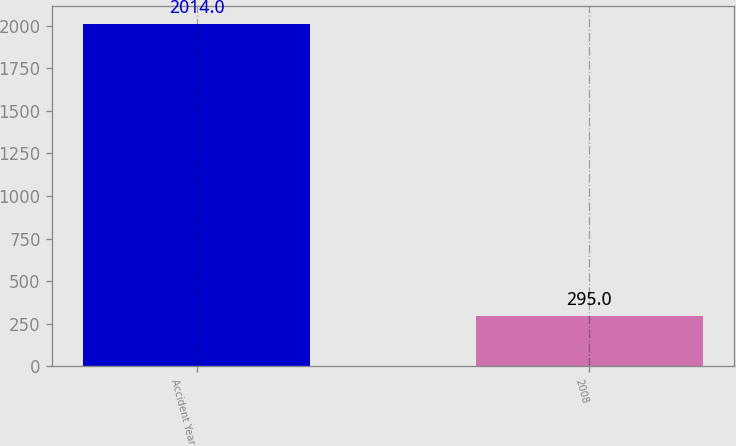Convert chart to OTSL. <chart><loc_0><loc_0><loc_500><loc_500><bar_chart><fcel>Accident Year<fcel>2008<nl><fcel>2014<fcel>295<nl></chart> 